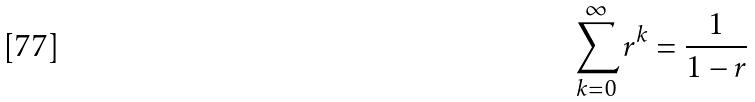<formula> <loc_0><loc_0><loc_500><loc_500>\sum _ { k = 0 } ^ { \infty } r ^ { k } = \frac { 1 } { 1 - r }</formula> 